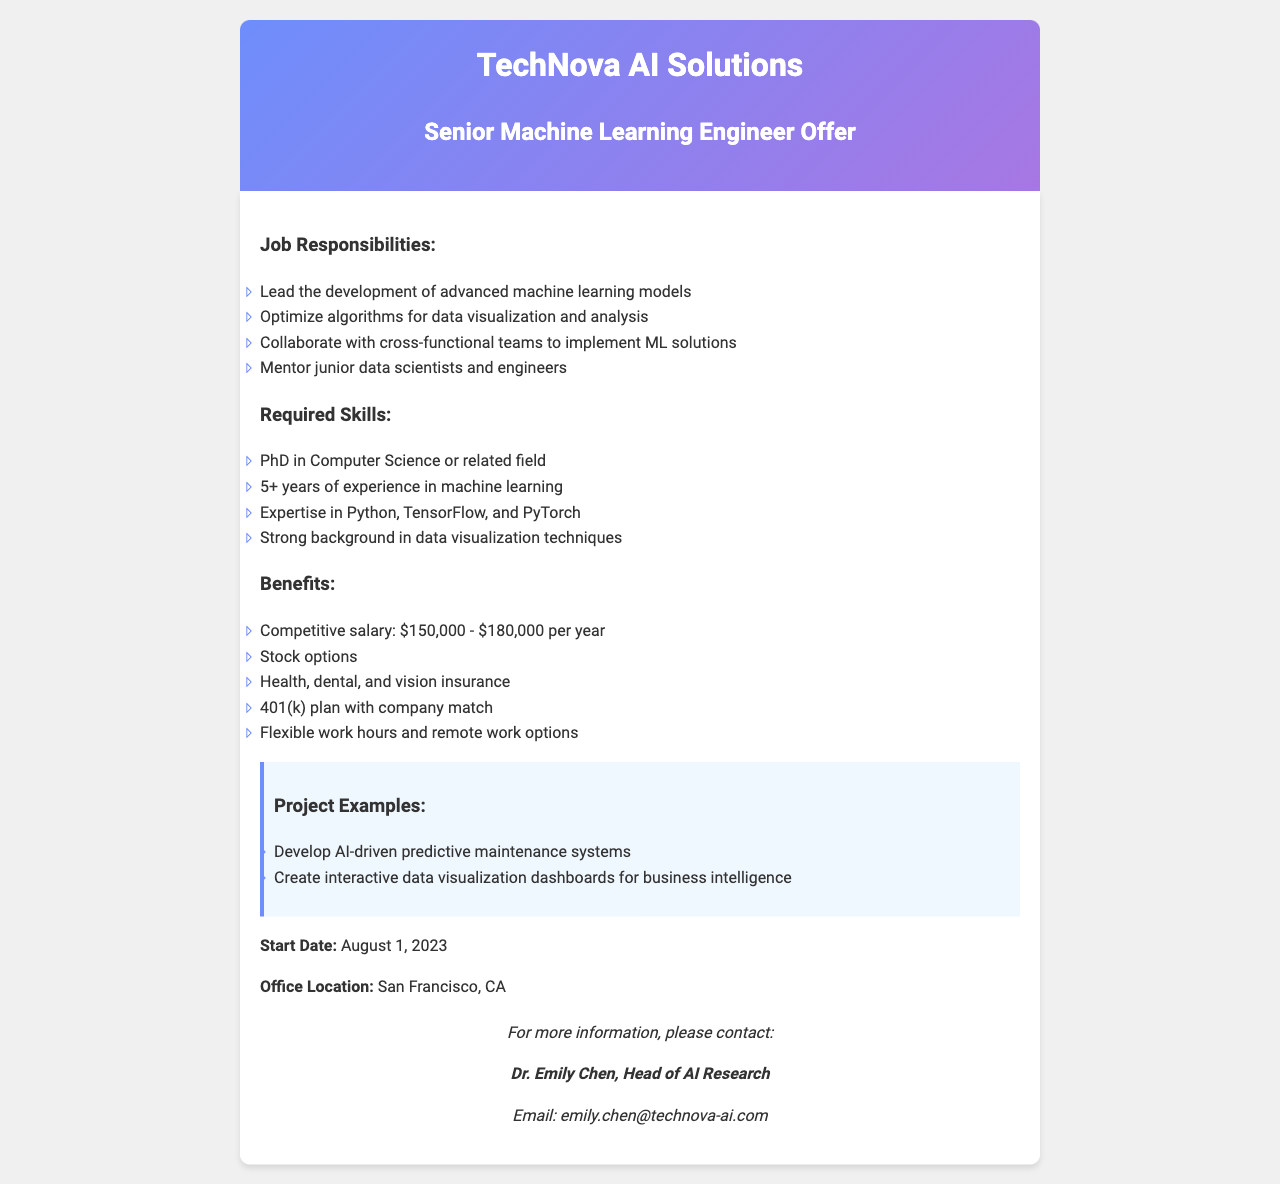what is the title of the position offered? The title of the position is stated in the heading of the document.
Answer: Senior Machine Learning Engineer Offer who is the head of AI research? The document lists the head of AI research in the contact information section.
Answer: Dr. Emily Chen what is the salary range for the position? The salary range can be found in the benefits section of the document.
Answer: $150,000 - $180,000 per year what are the required skills for the position? The required skills can be found in the job responsibilities section.
Answer: PhD in Computer Science or related field, 5+ years of experience in machine learning, expertise in Python, TensorFlow, and PyTorch, strong background in data visualization techniques when is the start date for the position? The start date is explicitly mentioned in the document.
Answer: August 1, 2023 which city is the office location? The office location is provided in the job offer document.
Answer: San Francisco, CA what types of insurance are provided as benefits? The benefits section lists the types of insurance included.
Answer: Health, dental, and vision insurance what is one example of a project mentioned? The document includes project examples in the highlight section.
Answer: Develop AI-driven predictive maintenance systems what is the company name? The company name appears in the heading of the document.
Answer: TechNova AI Solutions 